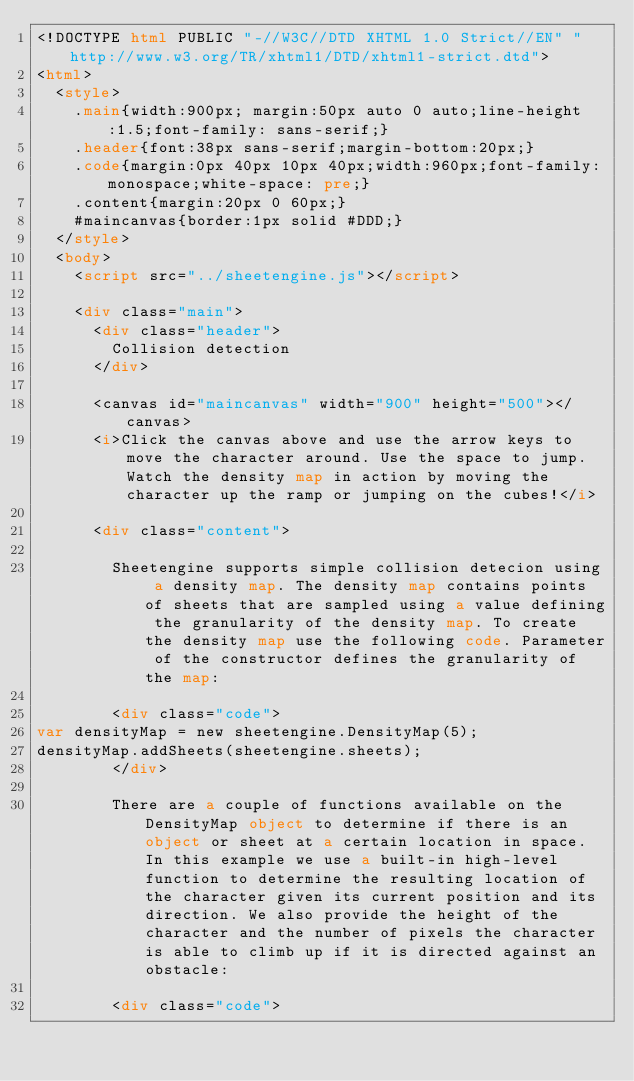Convert code to text. <code><loc_0><loc_0><loc_500><loc_500><_HTML_><!DOCTYPE html PUBLIC "-//W3C//DTD XHTML 1.0 Strict//EN" "http://www.w3.org/TR/xhtml1/DTD/xhtml1-strict.dtd">
<html>
  <style>
    .main{width:900px; margin:50px auto 0 auto;line-height:1.5;font-family: sans-serif;}
    .header{font:38px sans-serif;margin-bottom:20px;}
    .code{margin:0px 40px 10px 40px;width:960px;font-family:monospace;white-space: pre;}
    .content{margin:20px 0 60px;}
    #maincanvas{border:1px solid #DDD;}
  </style>
  <body>
    <script src="../sheetengine.js"></script>
    
    <div class="main">
      <div class="header">
        Collision detection
      </div>
      
      <canvas id="maincanvas" width="900" height="500"></canvas>
      <i>Click the canvas above and use the arrow keys to move the character around. Use the space to jump. Watch the density map in action by moving the character up the ramp or jumping on the cubes!</i>
      
      <div class="content">

        Sheetengine supports simple collision detecion using a density map. The density map contains points of sheets that are sampled using a value defining the granularity of the density map. To create the density map use the following code. Parameter of the constructor defines the granularity of the map:
        
        <div class="code">
var densityMap = new sheetengine.DensityMap(5);
densityMap.addSheets(sheetengine.sheets);
        </div>
        
        There are a couple of functions available on the DensityMap object to determine if there is an object or sheet at a certain location in space. In this example we use a built-in high-level function to determine the resulting location of the character given its current position and its direction. We also provide the height of the character and the number of pixels the character is able to climb up if it is directed against an obstacle:

        <div class="code"></code> 